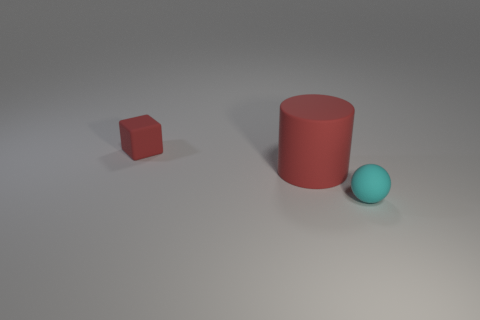Subtract all cyan cylinders. Subtract all cyan cubes. How many cylinders are left? 1 Add 3 red rubber cubes. How many objects exist? 6 Subtract all cylinders. How many objects are left? 2 Add 1 gray metallic spheres. How many gray metallic spheres exist? 1 Subtract 0 brown cylinders. How many objects are left? 3 Subtract all cylinders. Subtract all large red cylinders. How many objects are left? 1 Add 3 matte cylinders. How many matte cylinders are left? 4 